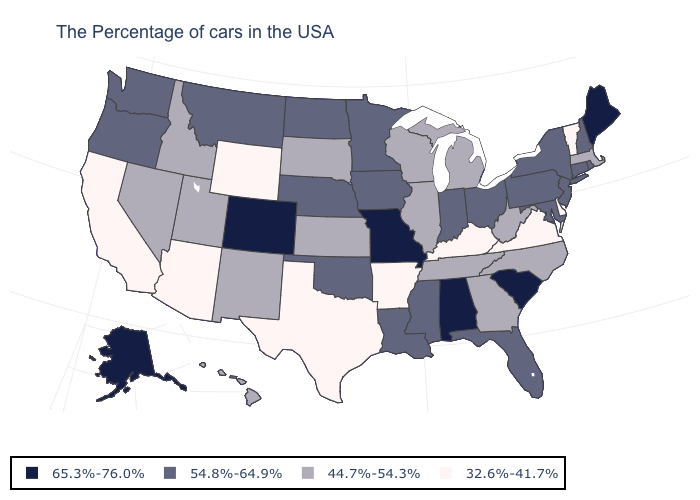Does the map have missing data?
Give a very brief answer. No. Which states have the lowest value in the USA?
Short answer required. Vermont, Delaware, Virginia, Kentucky, Arkansas, Texas, Wyoming, Arizona, California. What is the value of New York?
Quick response, please. 54.8%-64.9%. What is the highest value in states that border New Mexico?
Give a very brief answer. 65.3%-76.0%. What is the value of Michigan?
Quick response, please. 44.7%-54.3%. Does the map have missing data?
Short answer required. No. What is the value of Minnesota?
Give a very brief answer. 54.8%-64.9%. Does Nevada have a lower value than Delaware?
Give a very brief answer. No. Among the states that border Oklahoma , which have the highest value?
Concise answer only. Missouri, Colorado. What is the highest value in the USA?
Be succinct. 65.3%-76.0%. Name the states that have a value in the range 32.6%-41.7%?
Short answer required. Vermont, Delaware, Virginia, Kentucky, Arkansas, Texas, Wyoming, Arizona, California. What is the value of Colorado?
Give a very brief answer. 65.3%-76.0%. Name the states that have a value in the range 32.6%-41.7%?
Short answer required. Vermont, Delaware, Virginia, Kentucky, Arkansas, Texas, Wyoming, Arizona, California. What is the value of California?
Keep it brief. 32.6%-41.7%. Name the states that have a value in the range 32.6%-41.7%?
Short answer required. Vermont, Delaware, Virginia, Kentucky, Arkansas, Texas, Wyoming, Arizona, California. 